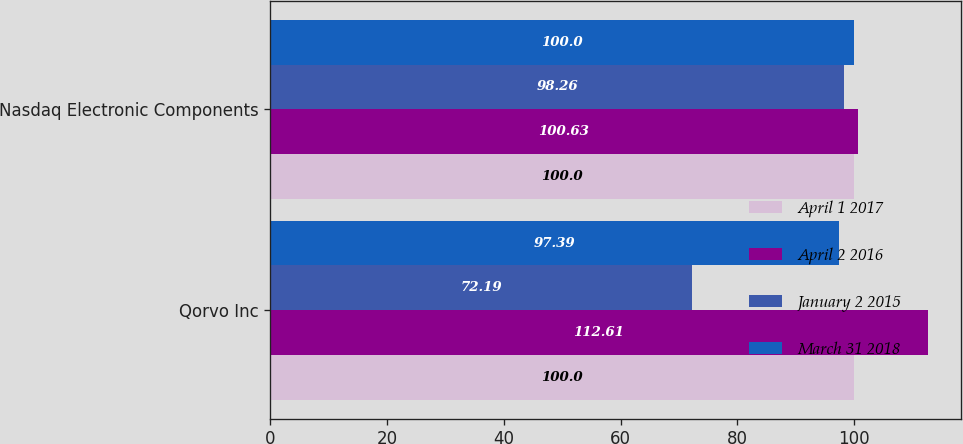<chart> <loc_0><loc_0><loc_500><loc_500><stacked_bar_chart><ecel><fcel>Qorvo Inc<fcel>Nasdaq Electronic Components<nl><fcel>April 1 2017<fcel>100<fcel>100<nl><fcel>April 2 2016<fcel>112.61<fcel>100.63<nl><fcel>January 2 2015<fcel>72.19<fcel>98.26<nl><fcel>March 31 2018<fcel>97.39<fcel>100<nl></chart> 